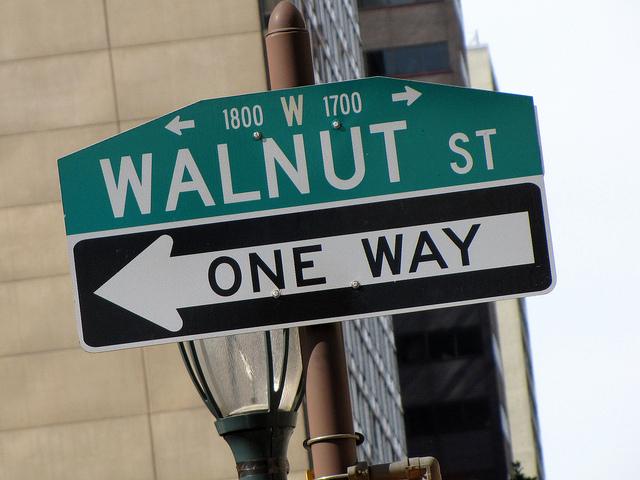What is the name of the street?
Be succinct. Walnut. Which way is walnut st?
Short answer required. Left and right. Is there a lantern next to the street sign?
Quick response, please. Yes. Are both street signs green?
Write a very short answer. No. 